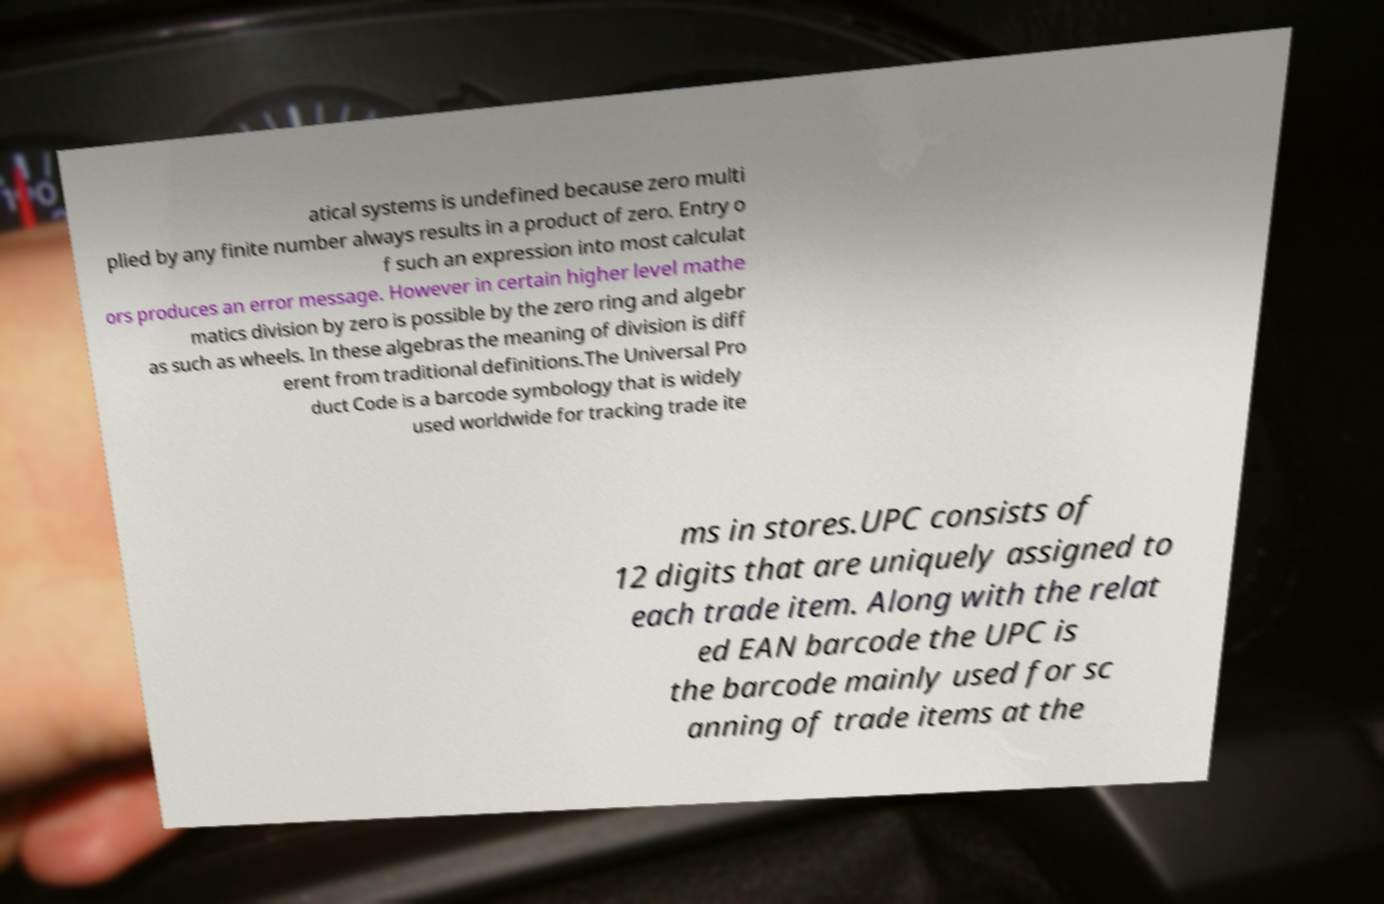Please identify and transcribe the text found in this image. atical systems is undefined because zero multi plied by any finite number always results in a product of zero. Entry o f such an expression into most calculat ors produces an error message. However in certain higher level mathe matics division by zero is possible by the zero ring and algebr as such as wheels. In these algebras the meaning of division is diff erent from traditional definitions.The Universal Pro duct Code is a barcode symbology that is widely used worldwide for tracking trade ite ms in stores.UPC consists of 12 digits that are uniquely assigned to each trade item. Along with the relat ed EAN barcode the UPC is the barcode mainly used for sc anning of trade items at the 